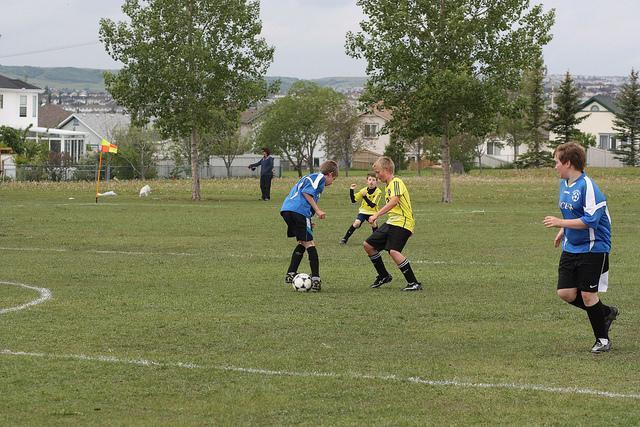How many people are in the picture?
Give a very brief answer. 3. 